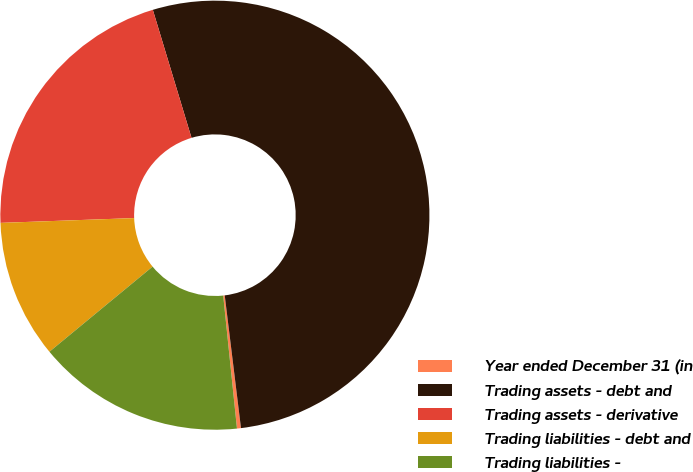<chart> <loc_0><loc_0><loc_500><loc_500><pie_chart><fcel>Year ended December 31 (in<fcel>Trading assets - debt and<fcel>Trading assets - derivative<fcel>Trading liabilities - debt and<fcel>Trading liabilities -<nl><fcel>0.3%<fcel>52.73%<fcel>20.9%<fcel>10.41%<fcel>15.66%<nl></chart> 